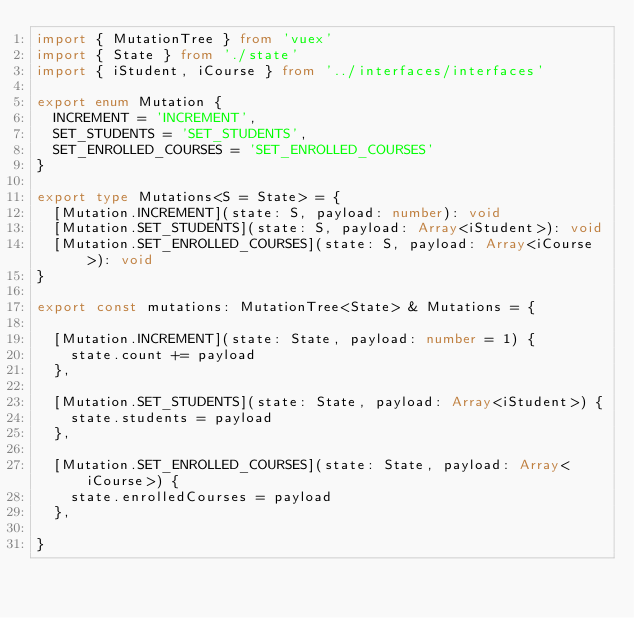Convert code to text. <code><loc_0><loc_0><loc_500><loc_500><_TypeScript_>import { MutationTree } from 'vuex'
import { State } from './state'
import { iStudent, iCourse } from '../interfaces/interfaces'

export enum Mutation {
  INCREMENT = 'INCREMENT',
  SET_STUDENTS = 'SET_STUDENTS',
  SET_ENROLLED_COURSES = 'SET_ENROLLED_COURSES'
}

export type Mutations<S = State> = {
  [Mutation.INCREMENT](state: S, payload: number): void
  [Mutation.SET_STUDENTS](state: S, payload: Array<iStudent>): void
  [Mutation.SET_ENROLLED_COURSES](state: S, payload: Array<iCourse>): void
}

export const mutations: MutationTree<State> & Mutations = {

  [Mutation.INCREMENT](state: State, payload: number = 1) {
    state.count += payload
  },

  [Mutation.SET_STUDENTS](state: State, payload: Array<iStudent>) {
    state.students = payload
  },

  [Mutation.SET_ENROLLED_COURSES](state: State, payload: Array<iCourse>) {
    state.enrolledCourses = payload
  },

}
</code> 